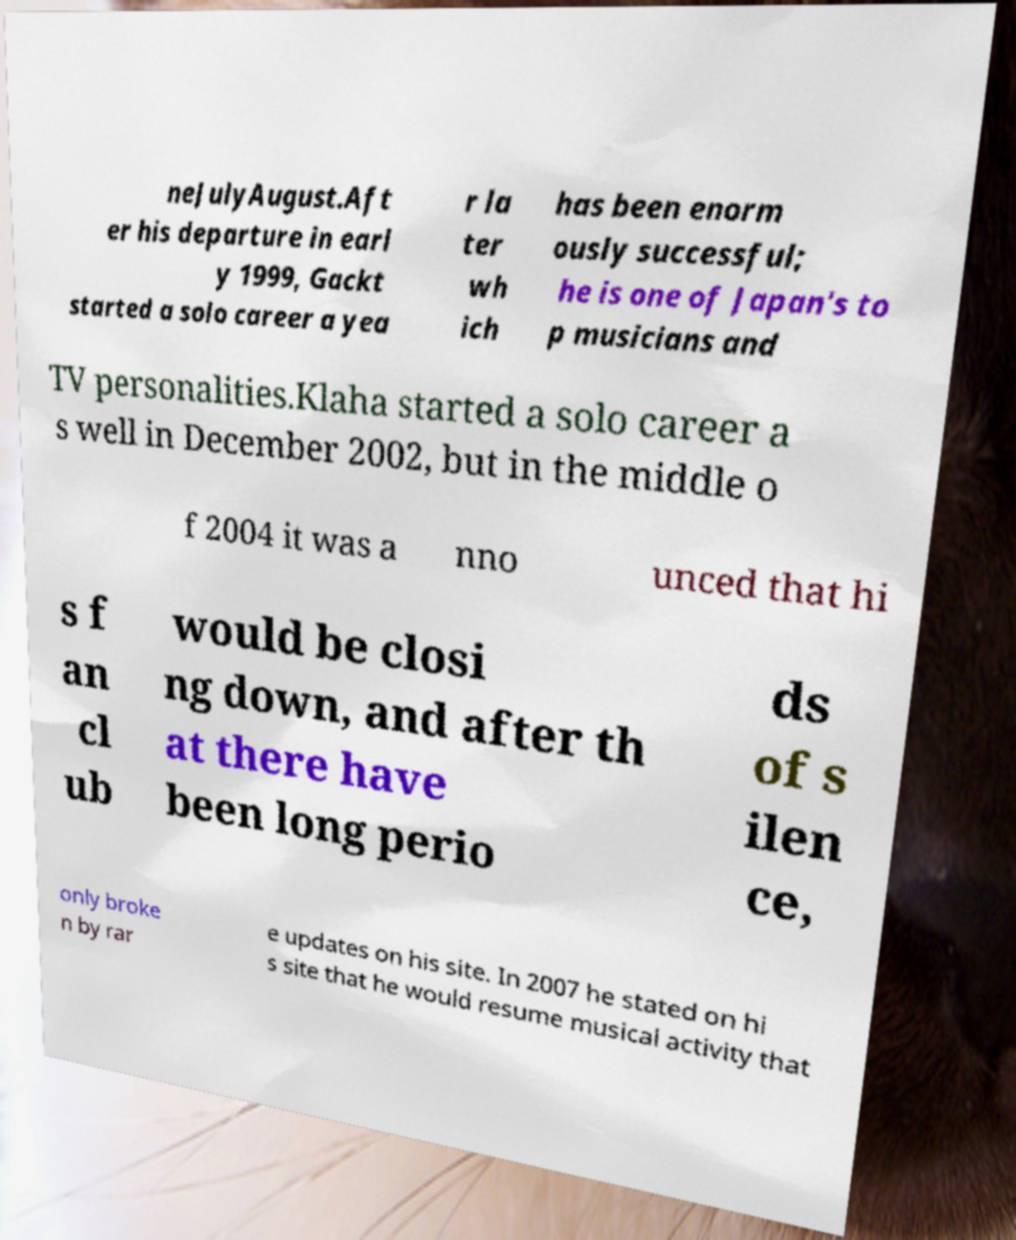Can you read and provide the text displayed in the image?This photo seems to have some interesting text. Can you extract and type it out for me? neJulyAugust.Aft er his departure in earl y 1999, Gackt started a solo career a yea r la ter wh ich has been enorm ously successful; he is one of Japan's to p musicians and TV personalities.Klaha started a solo career a s well in December 2002, but in the middle o f 2004 it was a nno unced that hi s f an cl ub would be closi ng down, and after th at there have been long perio ds of s ilen ce, only broke n by rar e updates on his site. In 2007 he stated on hi s site that he would resume musical activity that 